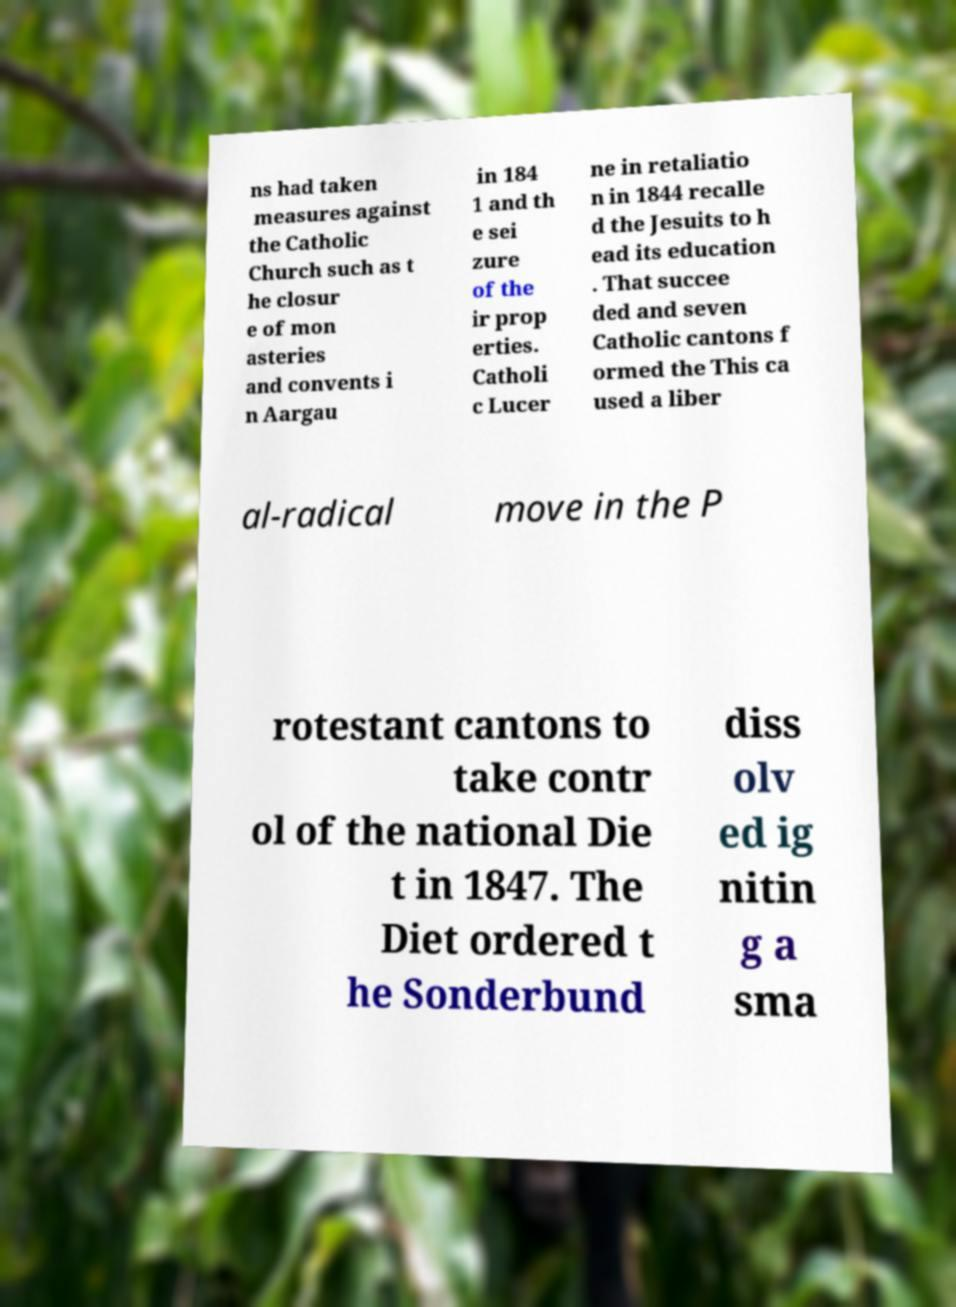Could you extract and type out the text from this image? ns had taken measures against the Catholic Church such as t he closur e of mon asteries and convents i n Aargau in 184 1 and th e sei zure of the ir prop erties. Catholi c Lucer ne in retaliatio n in 1844 recalle d the Jesuits to h ead its education . That succee ded and seven Catholic cantons f ormed the This ca used a liber al-radical move in the P rotestant cantons to take contr ol of the national Die t in 1847. The Diet ordered t he Sonderbund diss olv ed ig nitin g a sma 